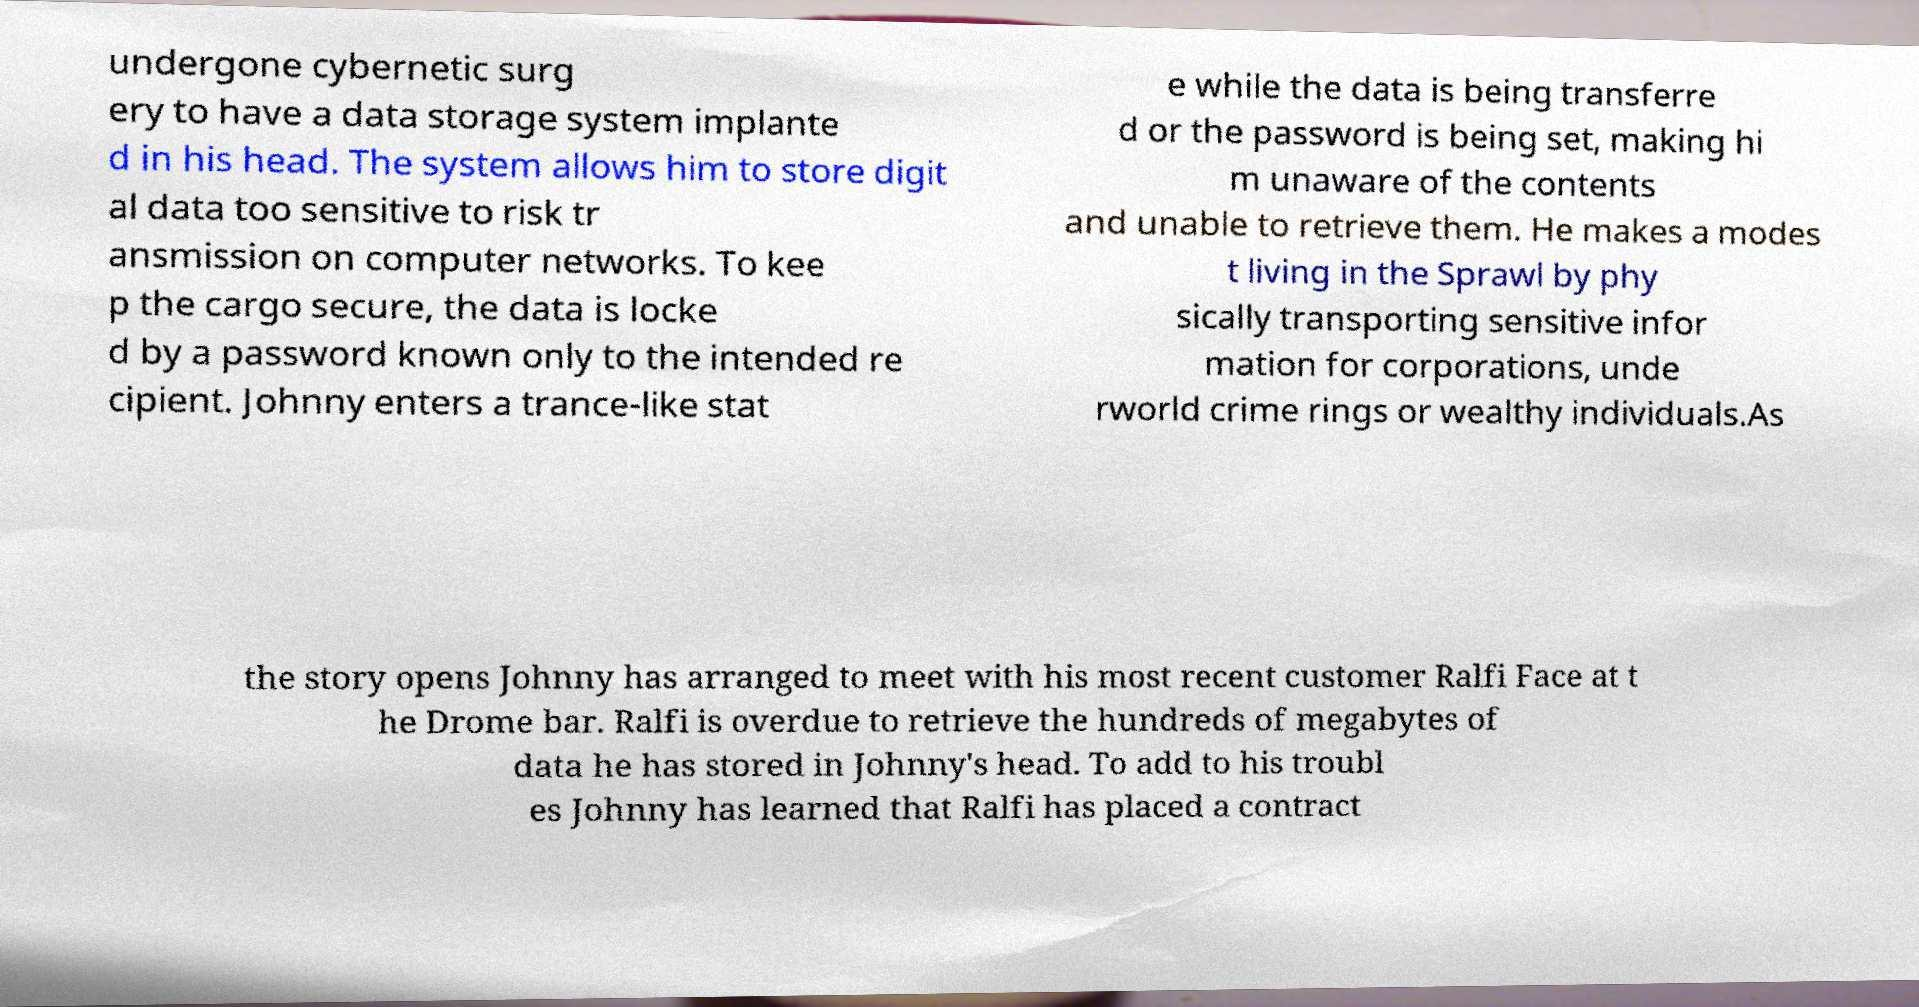Please identify and transcribe the text found in this image. undergone cybernetic surg ery to have a data storage system implante d in his head. The system allows him to store digit al data too sensitive to risk tr ansmission on computer networks. To kee p the cargo secure, the data is locke d by a password known only to the intended re cipient. Johnny enters a trance-like stat e while the data is being transferre d or the password is being set, making hi m unaware of the contents and unable to retrieve them. He makes a modes t living in the Sprawl by phy sically transporting sensitive infor mation for corporations, unde rworld crime rings or wealthy individuals.As the story opens Johnny has arranged to meet with his most recent customer Ralfi Face at t he Drome bar. Ralfi is overdue to retrieve the hundreds of megabytes of data he has stored in Johnny's head. To add to his troubl es Johnny has learned that Ralfi has placed a contract 